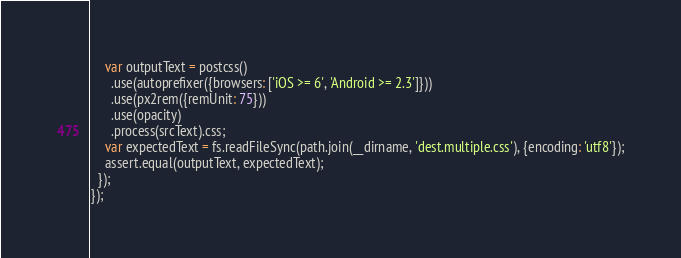<code> <loc_0><loc_0><loc_500><loc_500><_JavaScript_>    var outputText = postcss()
      .use(autoprefixer({browsers: ['iOS >= 6', 'Android >= 2.3']}))
      .use(px2rem({remUnit: 75}))
      .use(opacity)
      .process(srcText).css;
    var expectedText = fs.readFileSync(path.join(__dirname, 'dest.multiple.css'), {encoding: 'utf8'});
    assert.equal(outputText, expectedText);
  });
});
</code> 